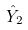<formula> <loc_0><loc_0><loc_500><loc_500>\hat { Y } _ { 2 }</formula> 